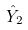<formula> <loc_0><loc_0><loc_500><loc_500>\hat { Y } _ { 2 }</formula> 